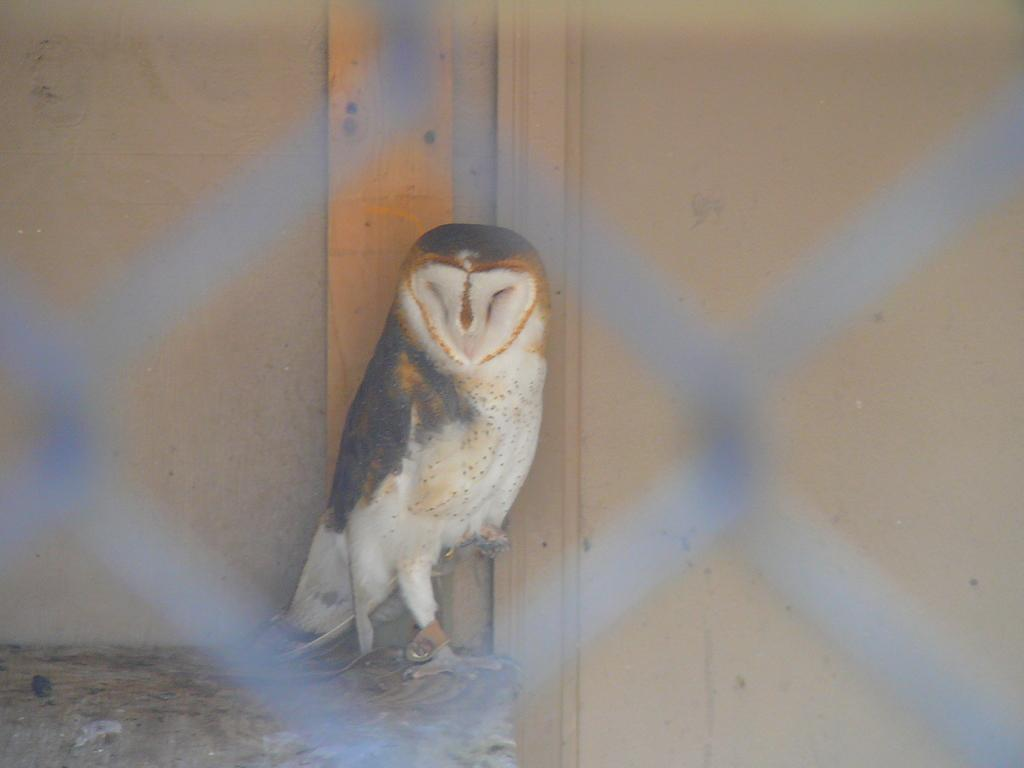What type of animal can be seen in the image? There is a bird in the image. Where is the bird located? The bird is on a stone. What can be seen in the background of the image? There is a wall in the background of the image. What is in front of the bird? There is a grill in front of the bird. How many visitors are present in the library in the image? There is no library or visitors present in the image; it features a bird on a stone with a grill in front of it. 